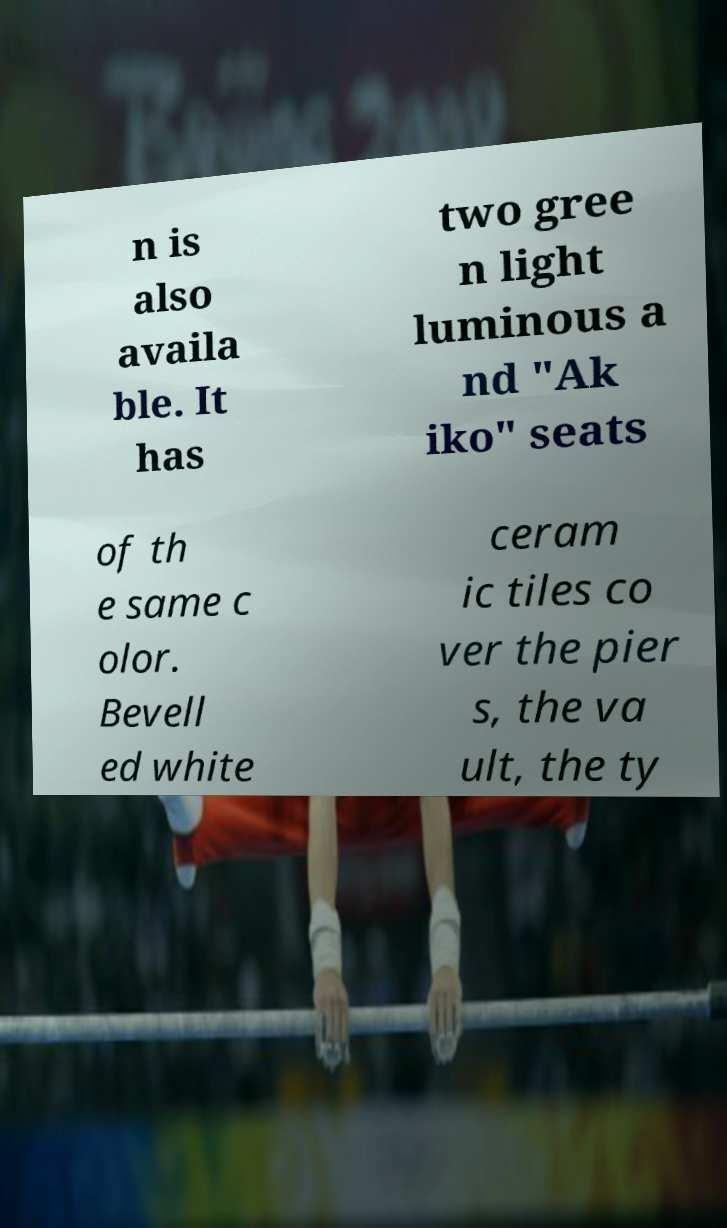I need the written content from this picture converted into text. Can you do that? n is also availa ble. It has two gree n light luminous a nd "Ak iko" seats of th e same c olor. Bevell ed white ceram ic tiles co ver the pier s, the va ult, the ty 